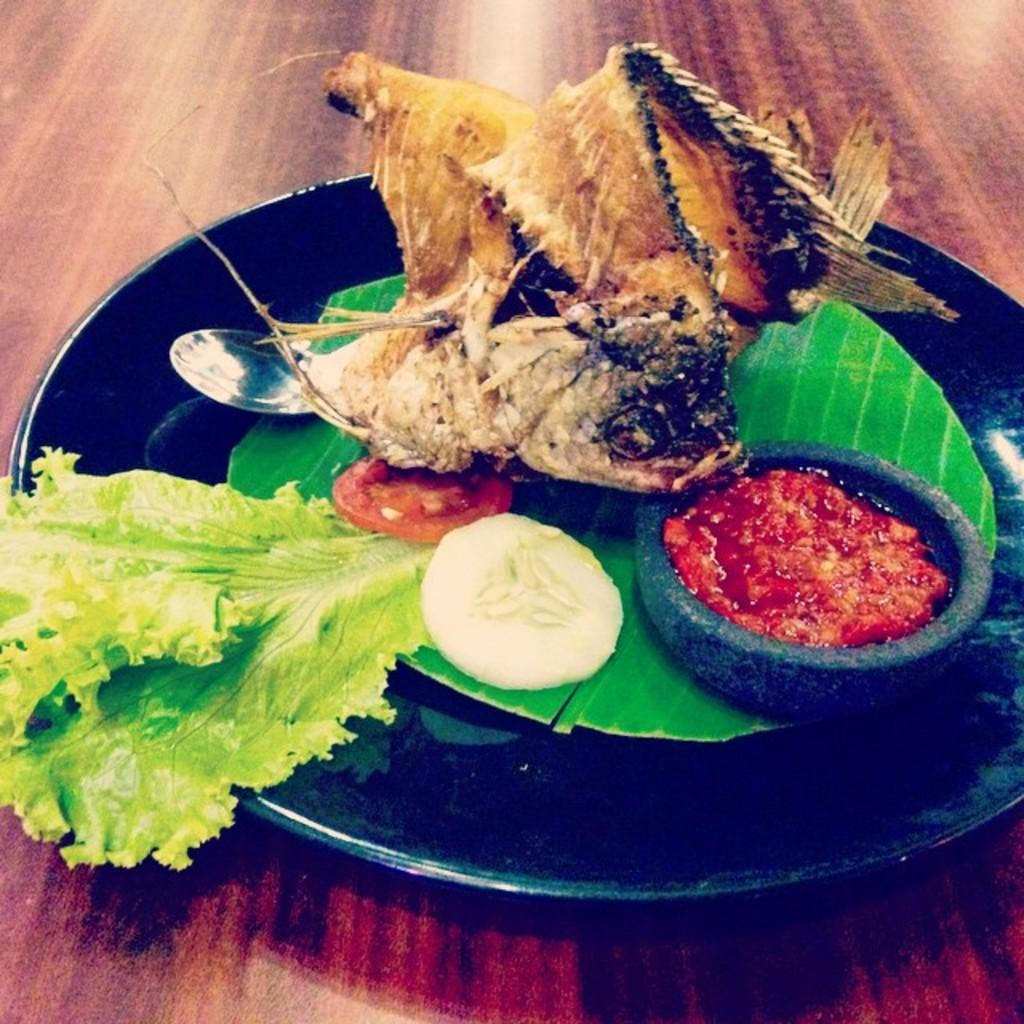What piece of furniture is present in the image? There is a table in the image. What is on the table? There is a plate containing food and a bowl placed on the table. What type of pipe can be seen running through the food on the plate? There is no pipe present in the image, and the food on the plate is not being affected by any pipes. 